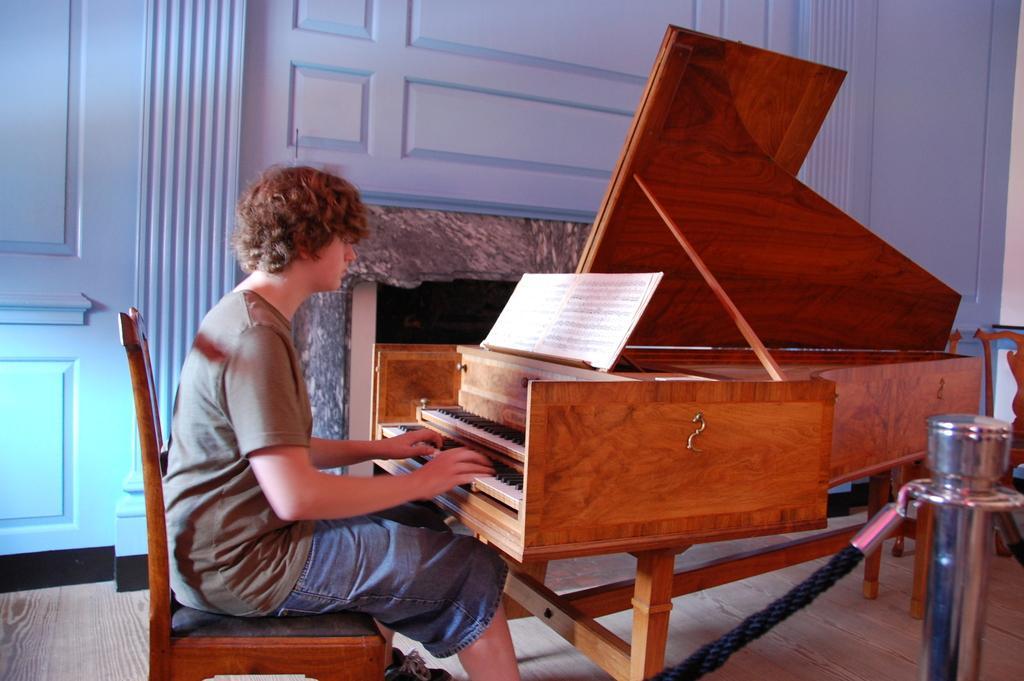In one or two sentences, can you explain what this image depicts? In this picture there is a man who is sitting on the chair. He is playing a piano. There is a book. There is a door and a rod. 